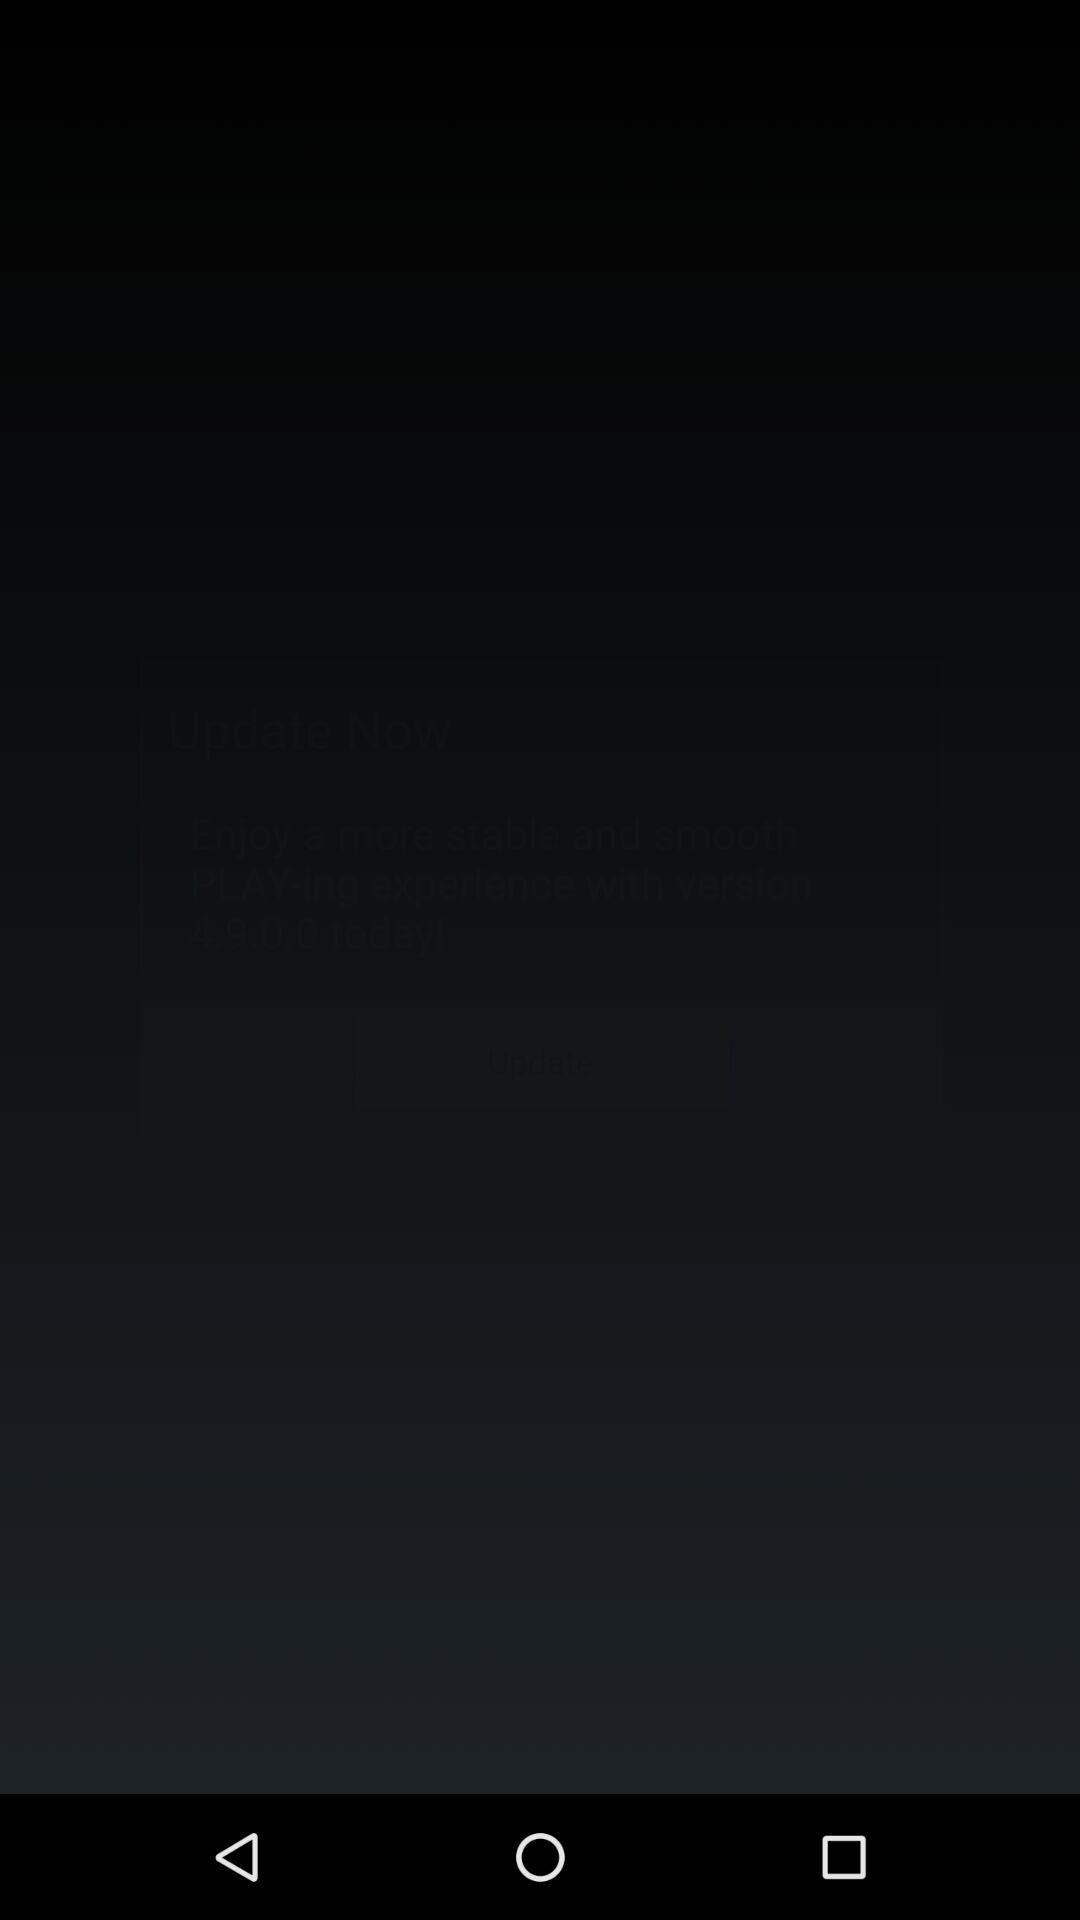How many languages are available for LINE PLAY?
Answer the question using a single word or phrase. 6 